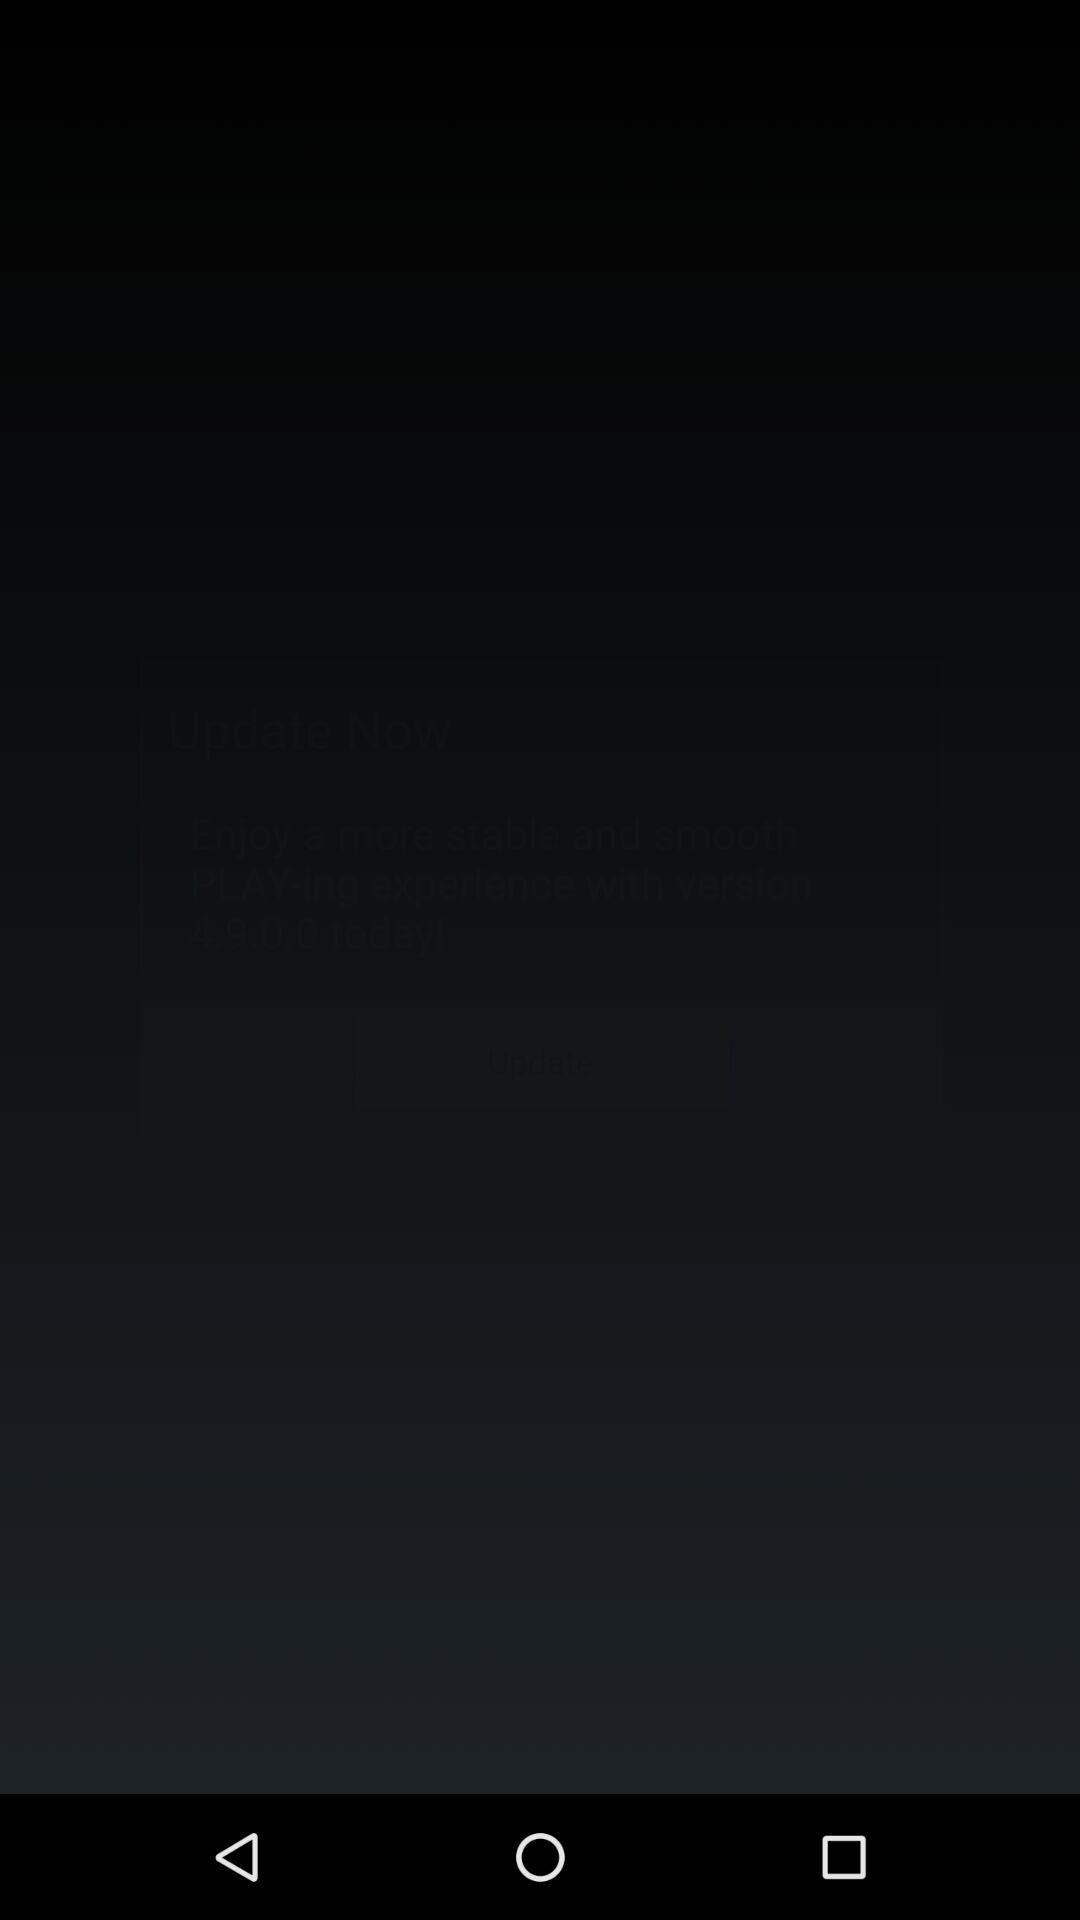How many languages are available for LINE PLAY?
Answer the question using a single word or phrase. 6 